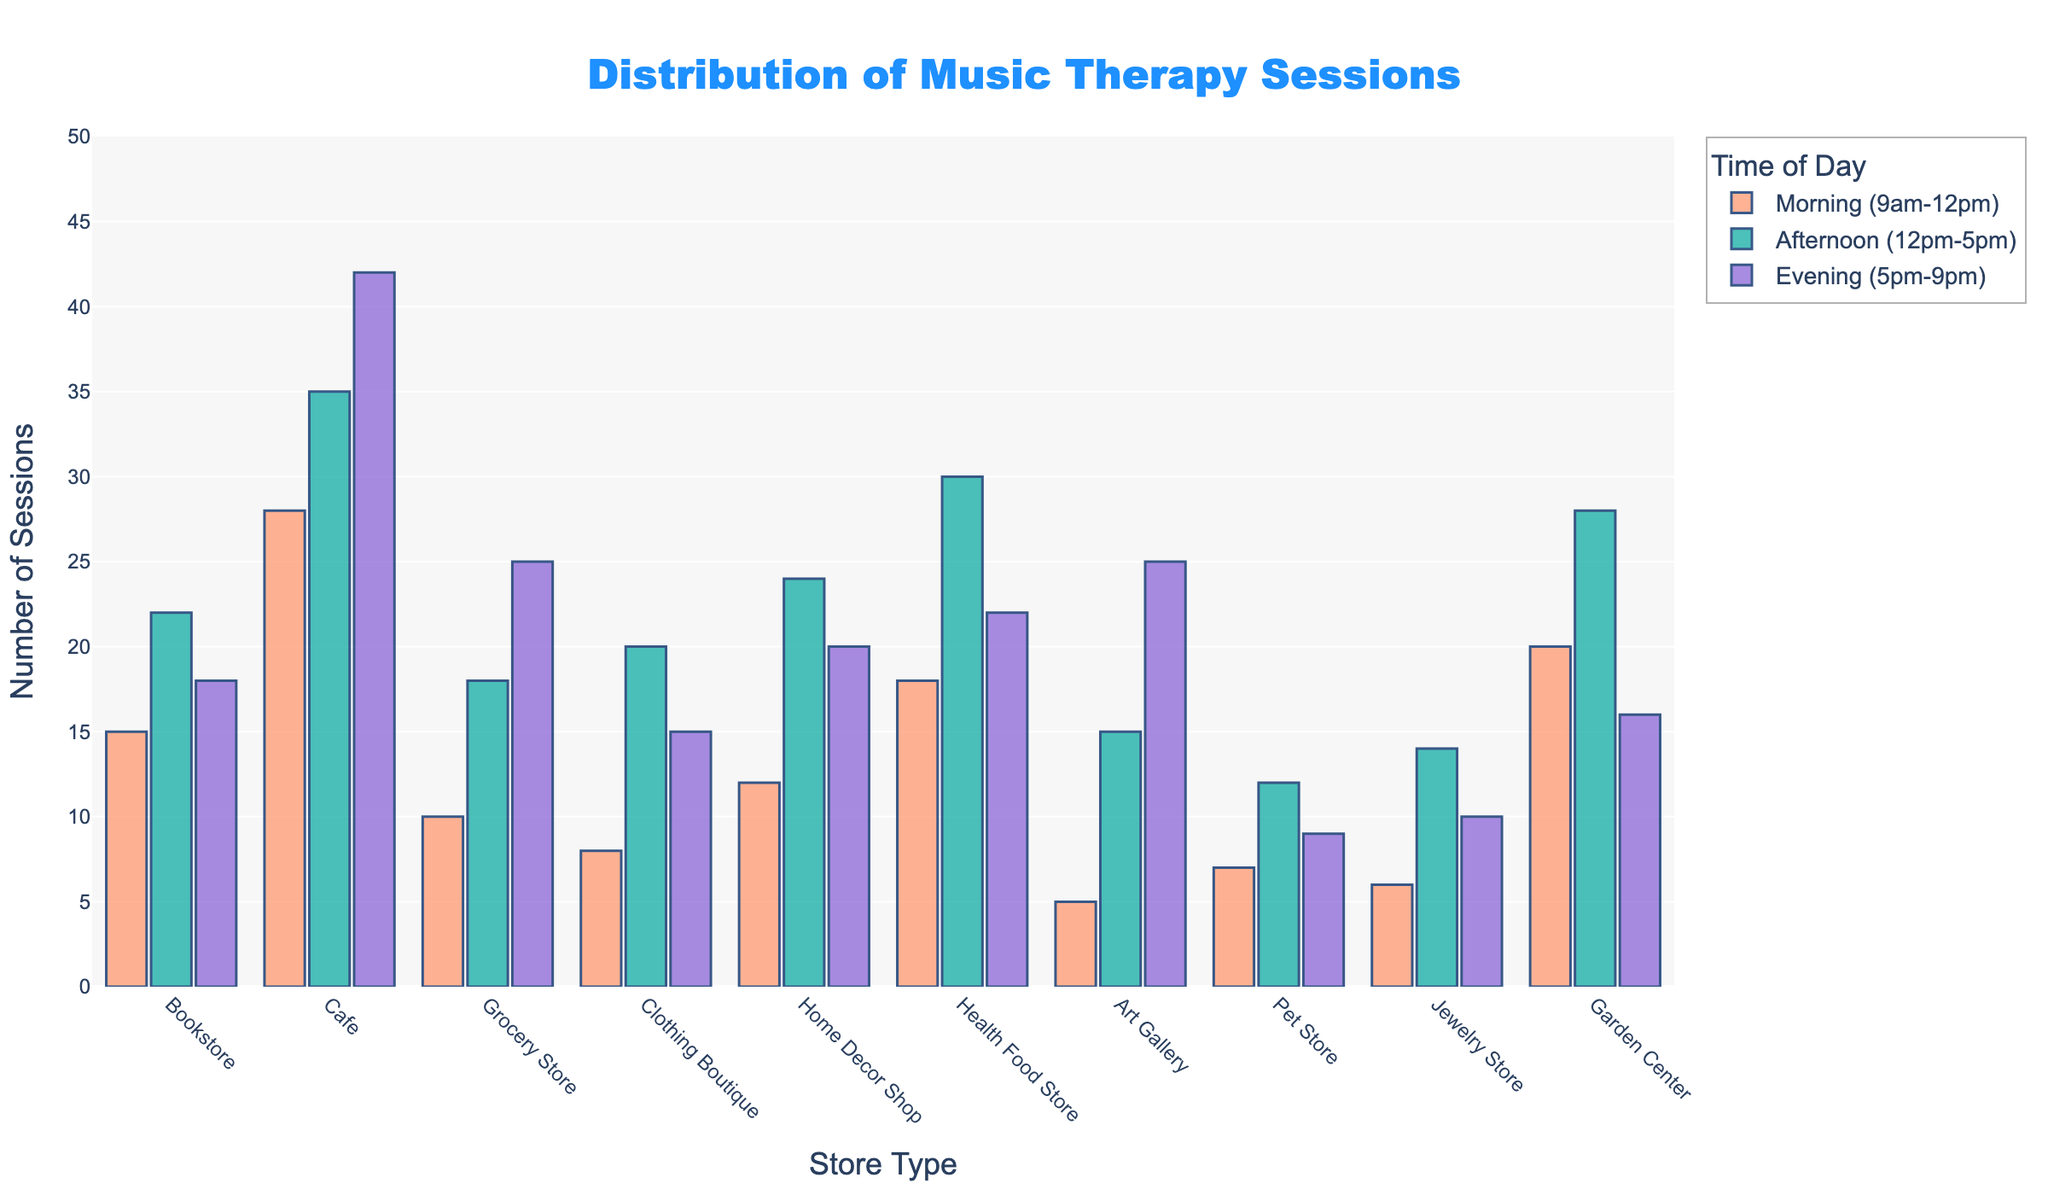What is the total number of music therapy sessions held in the evening across all store types? To find the total number of evening sessions, sum the evening sessions for all the store types: 18 (Bookstore) + 42 (Cafe) + 25 (Grocery Store) + 15 (Clothing Boutique) + 20 (Home Decor Shop) + 22 (Health Food Store) + 25 (Art Gallery) + 9 (Pet Store) + 10 (Jewelry Store) + 16 (Garden Center) = 202
Answer: 202 Which store type has the highest number of music therapy sessions in the morning? To determine the store type with the highest number of morning sessions, look at the tallest bar in the morning time across all store types. The Cafe has the highest morning sessions with 28 sessions.
Answer: Cafe Are there any store types where the number of sessions in the morning is equal to the number of sessions in the afternoon? Look for bars where the morning and afternoon values are equal. There are no store types with equal morning and afternoon sessions.
Answer: No What is the difference in the number of music therapy sessions between the morning and evening at the Garden Center? Subtract the number of evening sessions from the morning sessions at the Garden Center: 20 (morning) - 16 (evening) = 4
Answer: 4 Which store type has the least variation in the number of music therapy sessions across different times of the day? Calculate the range (max - min) of sessions for each store type. Bookstore: 22-15=7, Cafe: 42-28=14, Grocery Store: 25-10=15, Clothing Boutique: 20-8=12, Home Decor Shop: 24-12=12, Health Food Store: 30-18=12, Art Gallery: 25-5=20, Pet Store: 12-7=5, Jewelry Store: 14-6=8, Garden Center: 28-16=12. The Pet Store has the least variation (5).
Answer: Pet Store How many more sessions are held in the afternoon compared to the morning at the Health Food Store? Subtract the morning sessions from the afternoon sessions at the Health Food Store: 30 (afternoon) - 18 (morning) = 12
Answer: 12 What is the average number of music therapy sessions held at the Home Decor Shop across all times of the day? To find the average, sum the number of sessions across all times and divide by three: (12 + 24 + 20) / 3 = 56 / 3 ≈ 18.67
Answer: ≈18.67 Which time of day has the highest number of overall music therapy sessions? Sum the sessions for each time of day across all stores: Morning: 15+28+10+8+12+18+5+7+6+20=129, Afternoon: 22+35+18+20+24+30+15+12+14+28=218, Evening: 18+42+25+15+20+22+25+9+10+16=202. Afternoon has the highest total with 218.
Answer: Afternoon What is the range in the number of sessions held in the afternoon across all store types? Identify the highest and lowest values for the afternoon sessions and subtract the smallest from the largest: Highest: 35 (Cafe), Lowest: 12 (Pet Store), Range: 35 - 12 = 23
Answer: 23 Which store type has an equal number of sessions in the evening and morning? Compare the bars for each store type for morning and evening sessions. The Art Gallery has equal sessions in the morning and evening with 25 each.
Answer: Art Gallery 